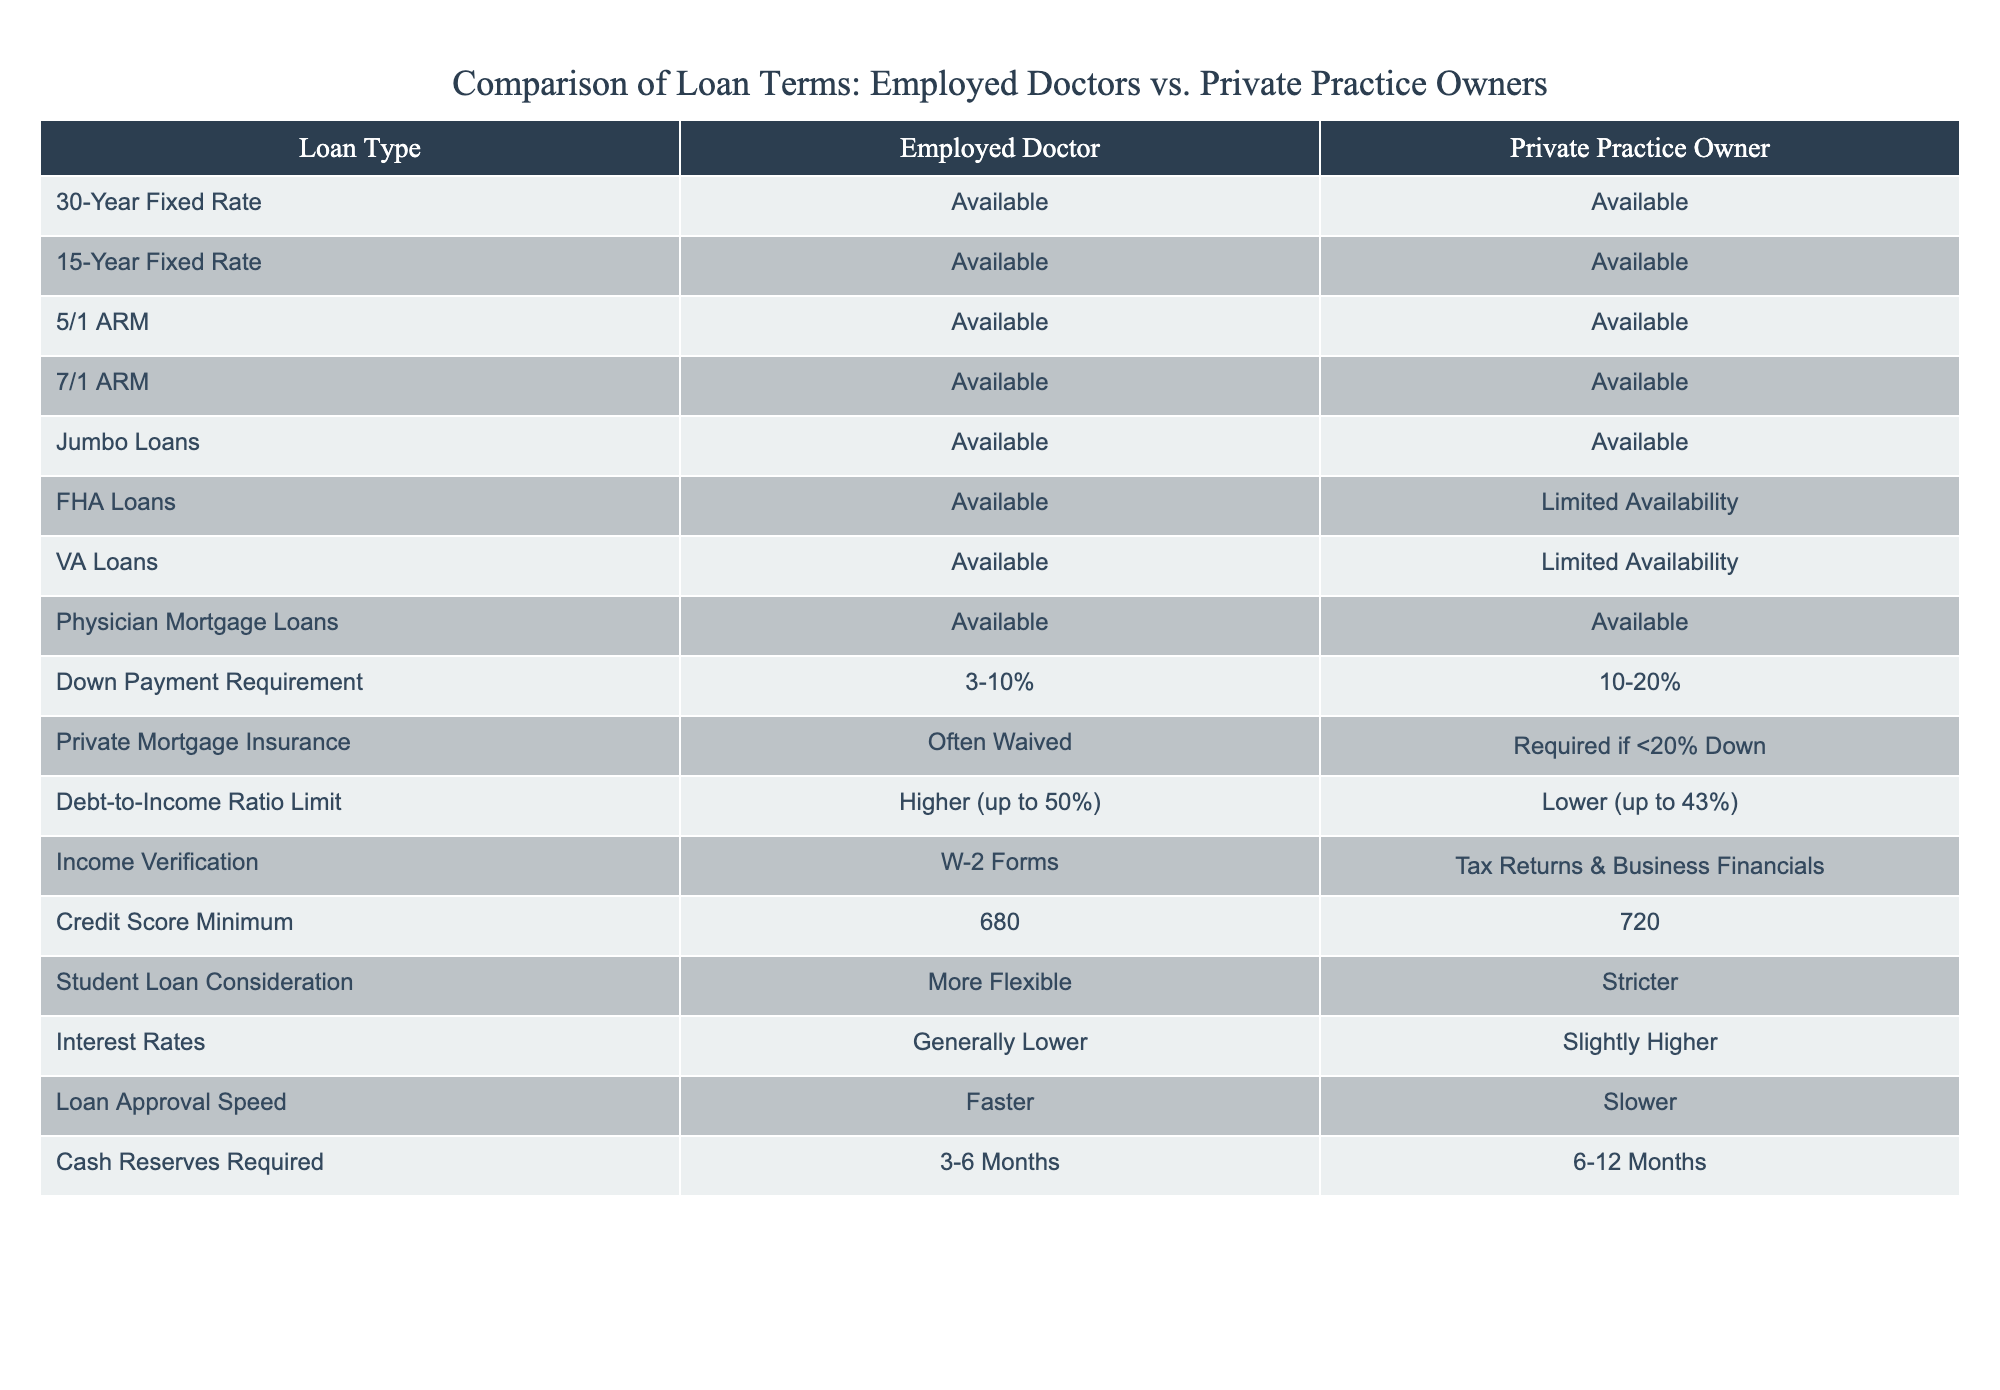What types of loans are available for both employed doctors and private practice owners? Both categories have access to a range of loan types, as indicated in the table. The types listed include 30-Year Fixed Rate, 15-Year Fixed Rate, 5/1 ARM, 7/1 ARM, Jumbo Loans, FHA Loans, VA Loans, and Physician Mortgage Loans, all of which are marked as 'Available' for both.
Answer: 30-Year Fixed Rate, 15-Year Fixed Rate, 5/1 ARM, 7/1 ARM, Jumbo Loans, FHA Loans, VA Loans, Physician Mortgage Loans Is the down payment requirement higher for employed doctors than for private practice owners? The table indicates that employed doctors have a down payment requirement of 3-10% while private practice owners have a requirement of 10-20%. Since 10-20% is greater than 3-10%, the statement is false.
Answer: No What is the credit score minimum for private practice owners? The table specifies that the credit score minimum for private practice owners is 720. This can be referenced directly from the 'Credit Score Minimum' row under 'Private Practice Owner'.
Answer: 720 How do the interest rates compare between employed doctors and private practice owners? According to the table, interest rates for employed doctors are generally lower than those for private practice owners, who have slightly higher rates. Thus, in a comparative context, employed doctors benefit from lower interest rates.
Answer: Lower for employed doctors What is the difference in debt-to-income ratio limits between the two categories? The table states that the debt-to-income ratio limit is higher for employed doctors, with a limit up to 50%, while for private practice owners it is lower, at up to 43%. The difference is 50% - 43% = 7%.
Answer: 7% Are cash reserves required for private practice owners greater than those for employed doctors? Yes, the table shows that cash reserves required for employed doctors range from 3-6 months, whereas private practice owners require reserves of 6-12 months, indicating that the requirement is indeed greater for private practice owners.
Answer: Yes What types of loans have limited availability for private practice owners? The table lists FHA Loans and VA Loans as having 'Limited Availability' for private practice owners, while these loans are fully available to employed doctors. This represents a difference in loan accessibility.
Answer: FHA Loans and VA Loans Which category has a faster loan approval speed? The table indicates that employed doctors have a faster loan approval speed compared to private practice owners, who experience a slower process. This comparison is straightforward based on the 'Loan Approval Speed' row.
Answer: Employed doctors How do the requirements for income verification differ between employed doctors and private practice owners? The table shows that employed doctors can rely on W-2 forms for income verification, while private practice owners must provide tax returns and business financials. This represents a significant difference in documentation requirements.
Answer: Different requirements: W-2 for employed doctors, tax returns & business financials for private practice owners 